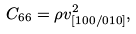Convert formula to latex. <formula><loc_0><loc_0><loc_500><loc_500>C _ { 6 6 } = \rho v _ { [ 1 0 0 / 0 1 0 ] } ^ { 2 } ,</formula> 